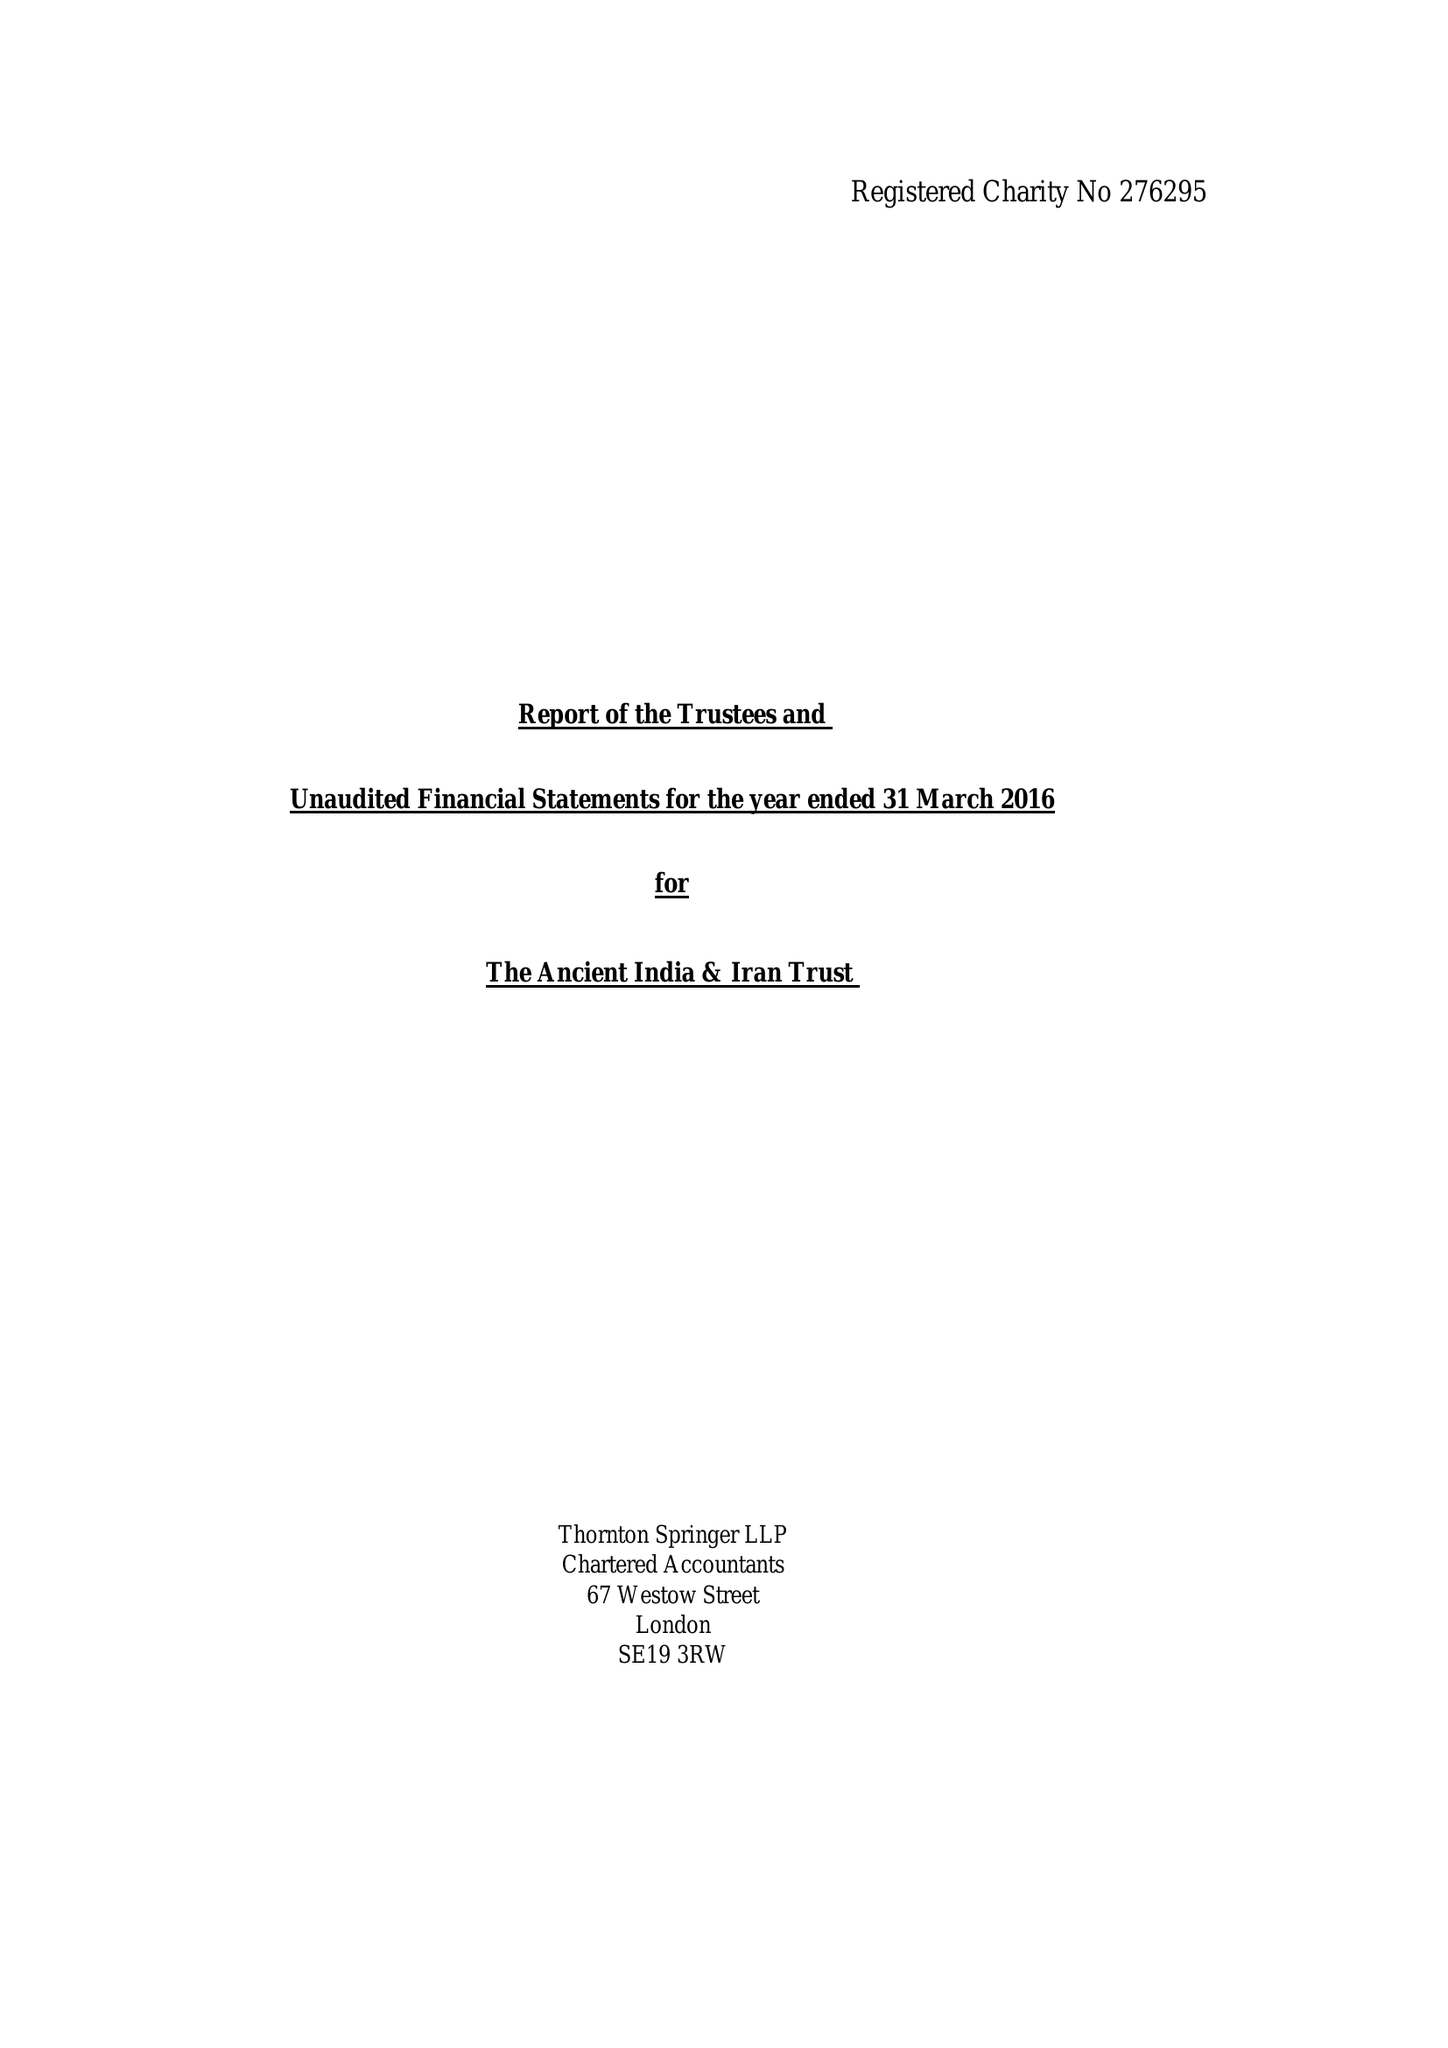What is the value for the report_date?
Answer the question using a single word or phrase. 2016-03-31 